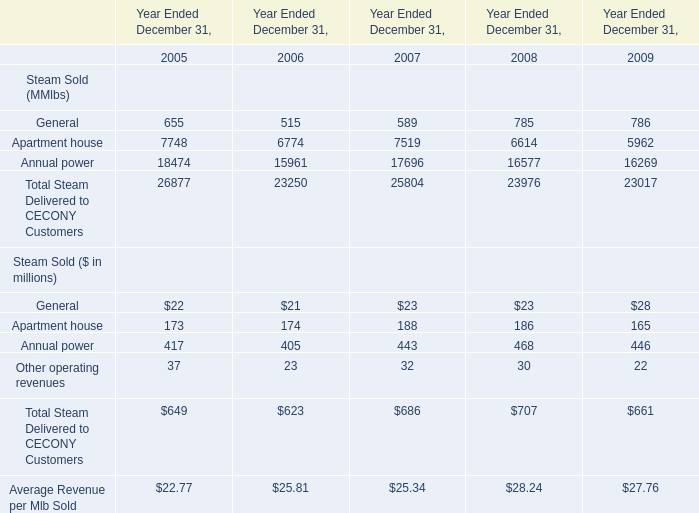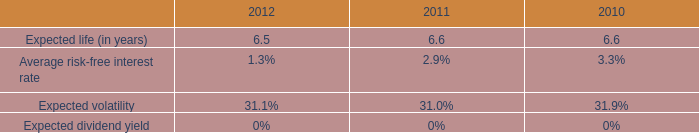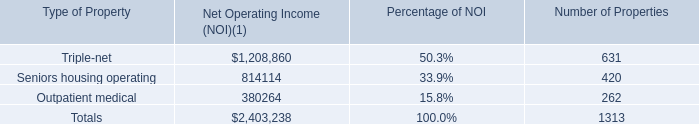How many Apartment house exceed the average of Annual power in 2005? 
Answer: 0. 